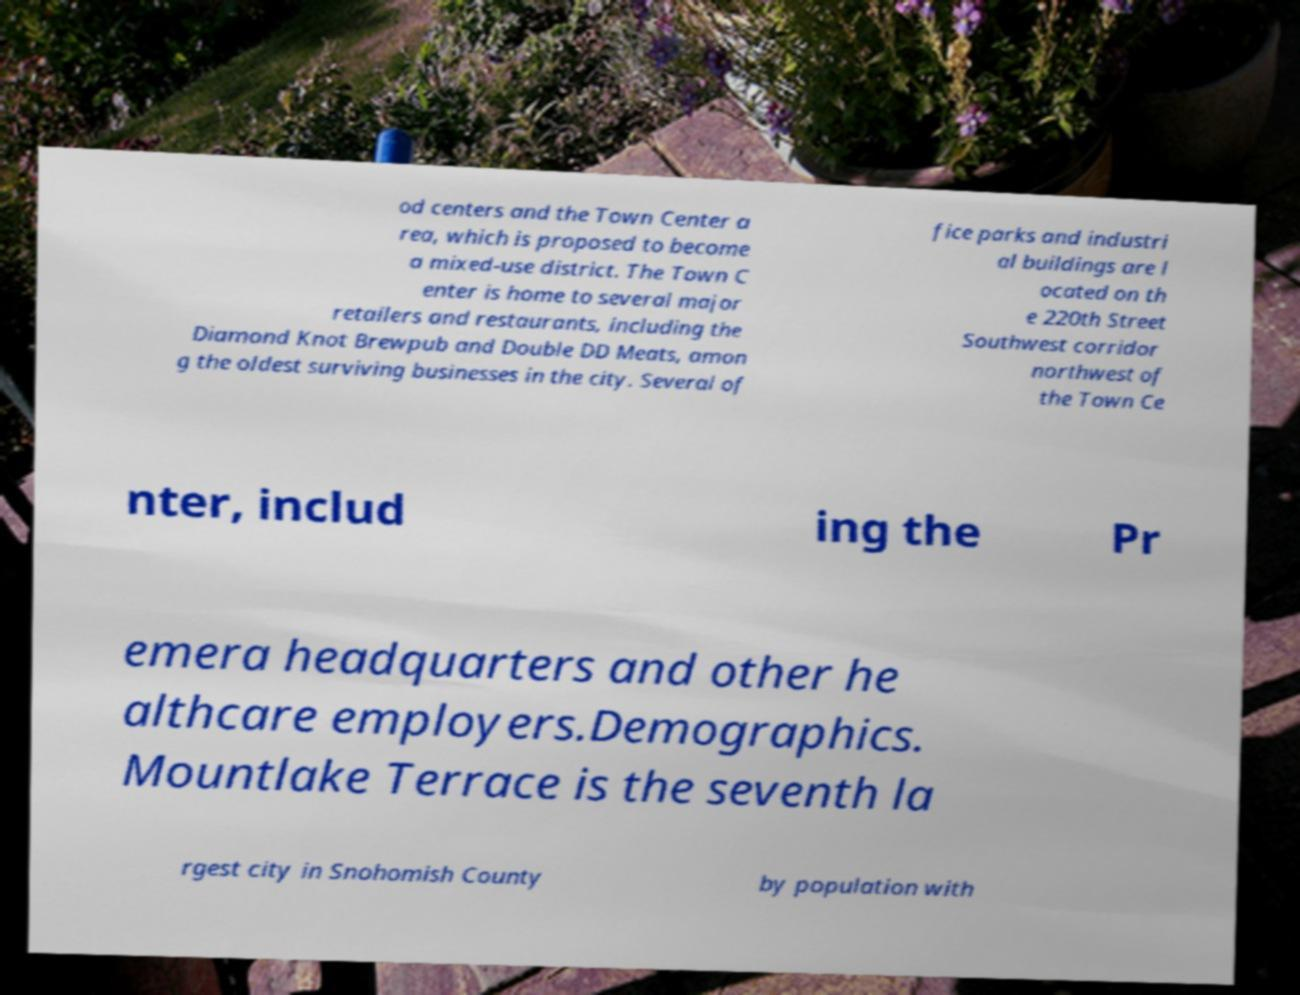I need the written content from this picture converted into text. Can you do that? od centers and the Town Center a rea, which is proposed to become a mixed-use district. The Town C enter is home to several major retailers and restaurants, including the Diamond Knot Brewpub and Double DD Meats, amon g the oldest surviving businesses in the city. Several of fice parks and industri al buildings are l ocated on th e 220th Street Southwest corridor northwest of the Town Ce nter, includ ing the Pr emera headquarters and other he althcare employers.Demographics. Mountlake Terrace is the seventh la rgest city in Snohomish County by population with 